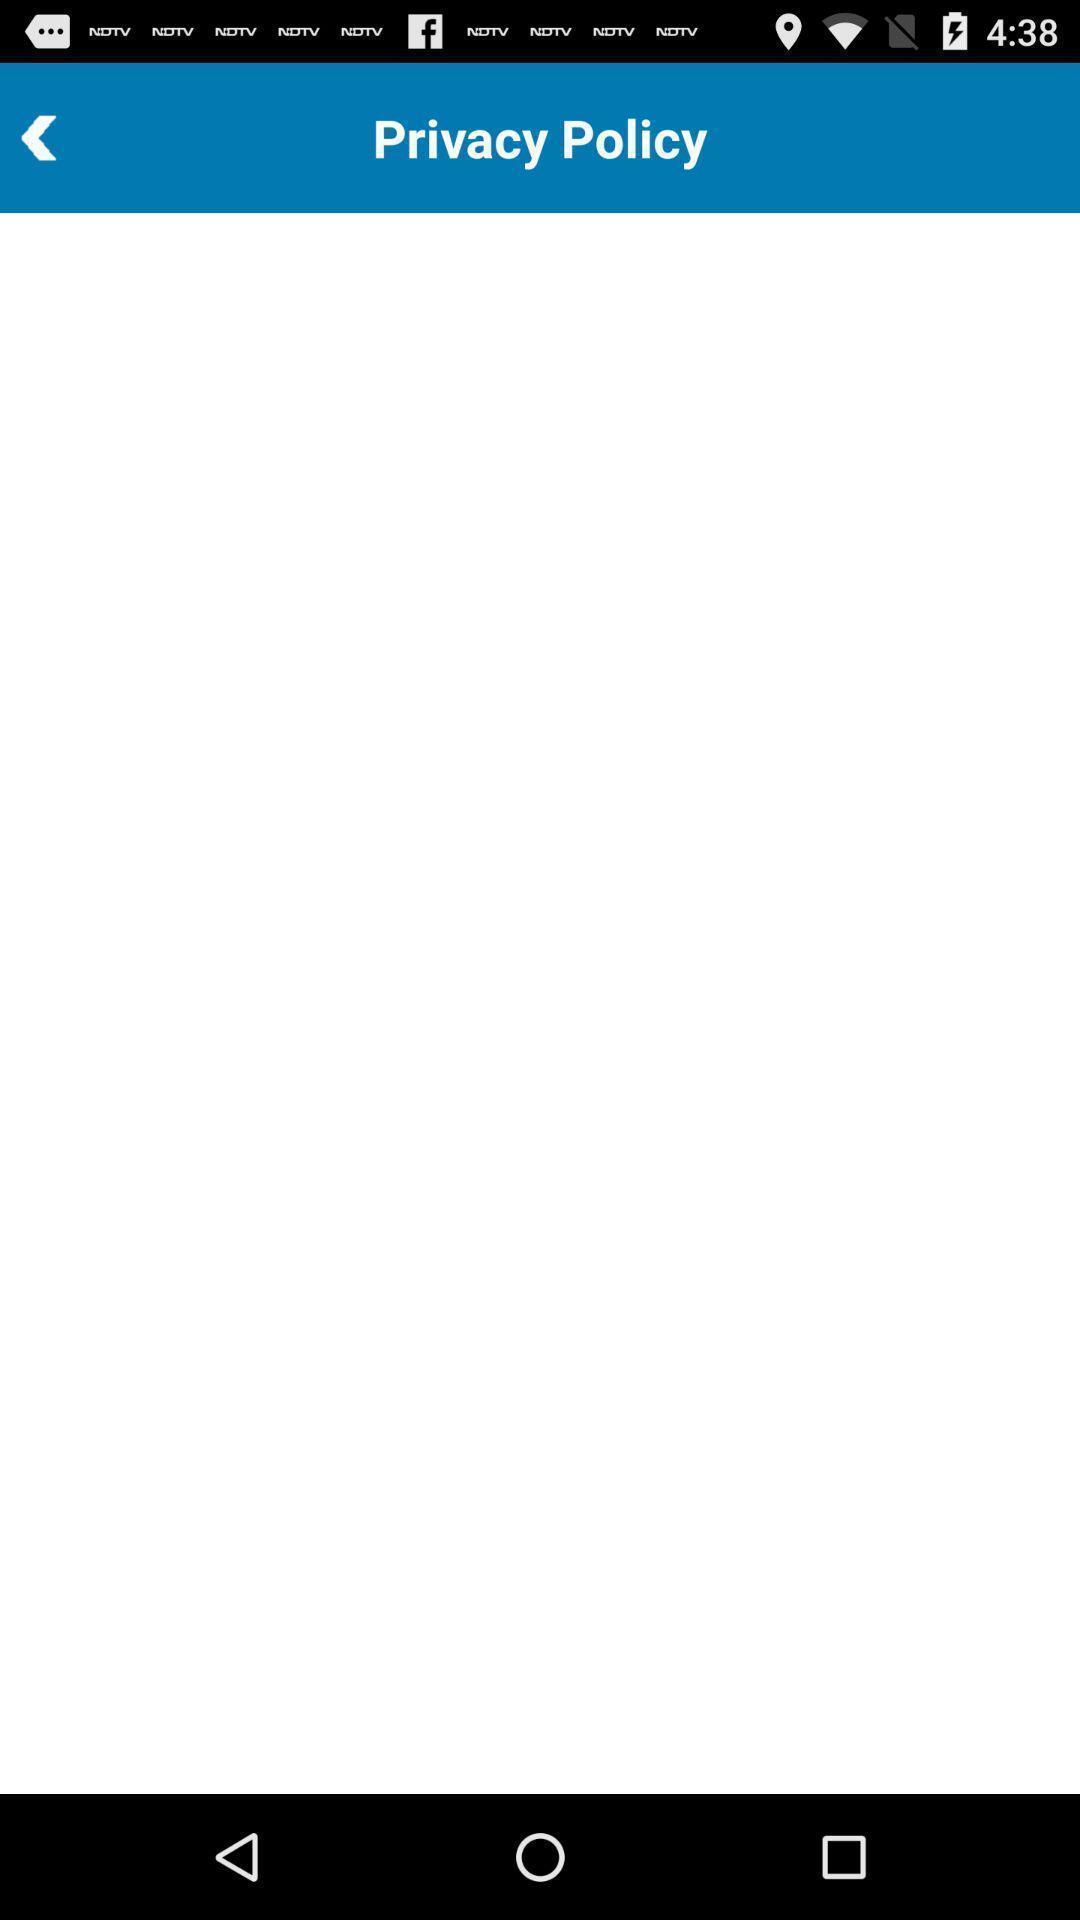Provide a detailed account of this screenshot. Screen showing privacy policy page for an app. 